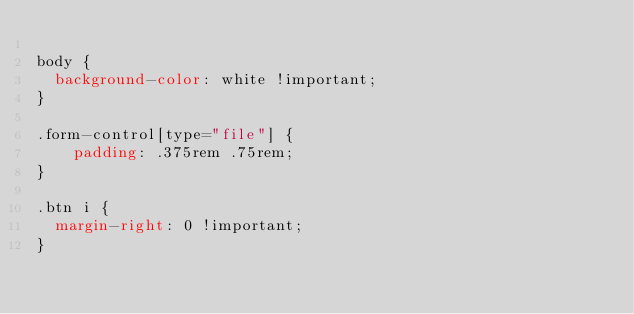Convert code to text. <code><loc_0><loc_0><loc_500><loc_500><_CSS_>
body {
	background-color: white !important;
}

.form-control[type="file"] {
    padding: .375rem .75rem;
}

.btn i {
	margin-right: 0 !important;
}</code> 